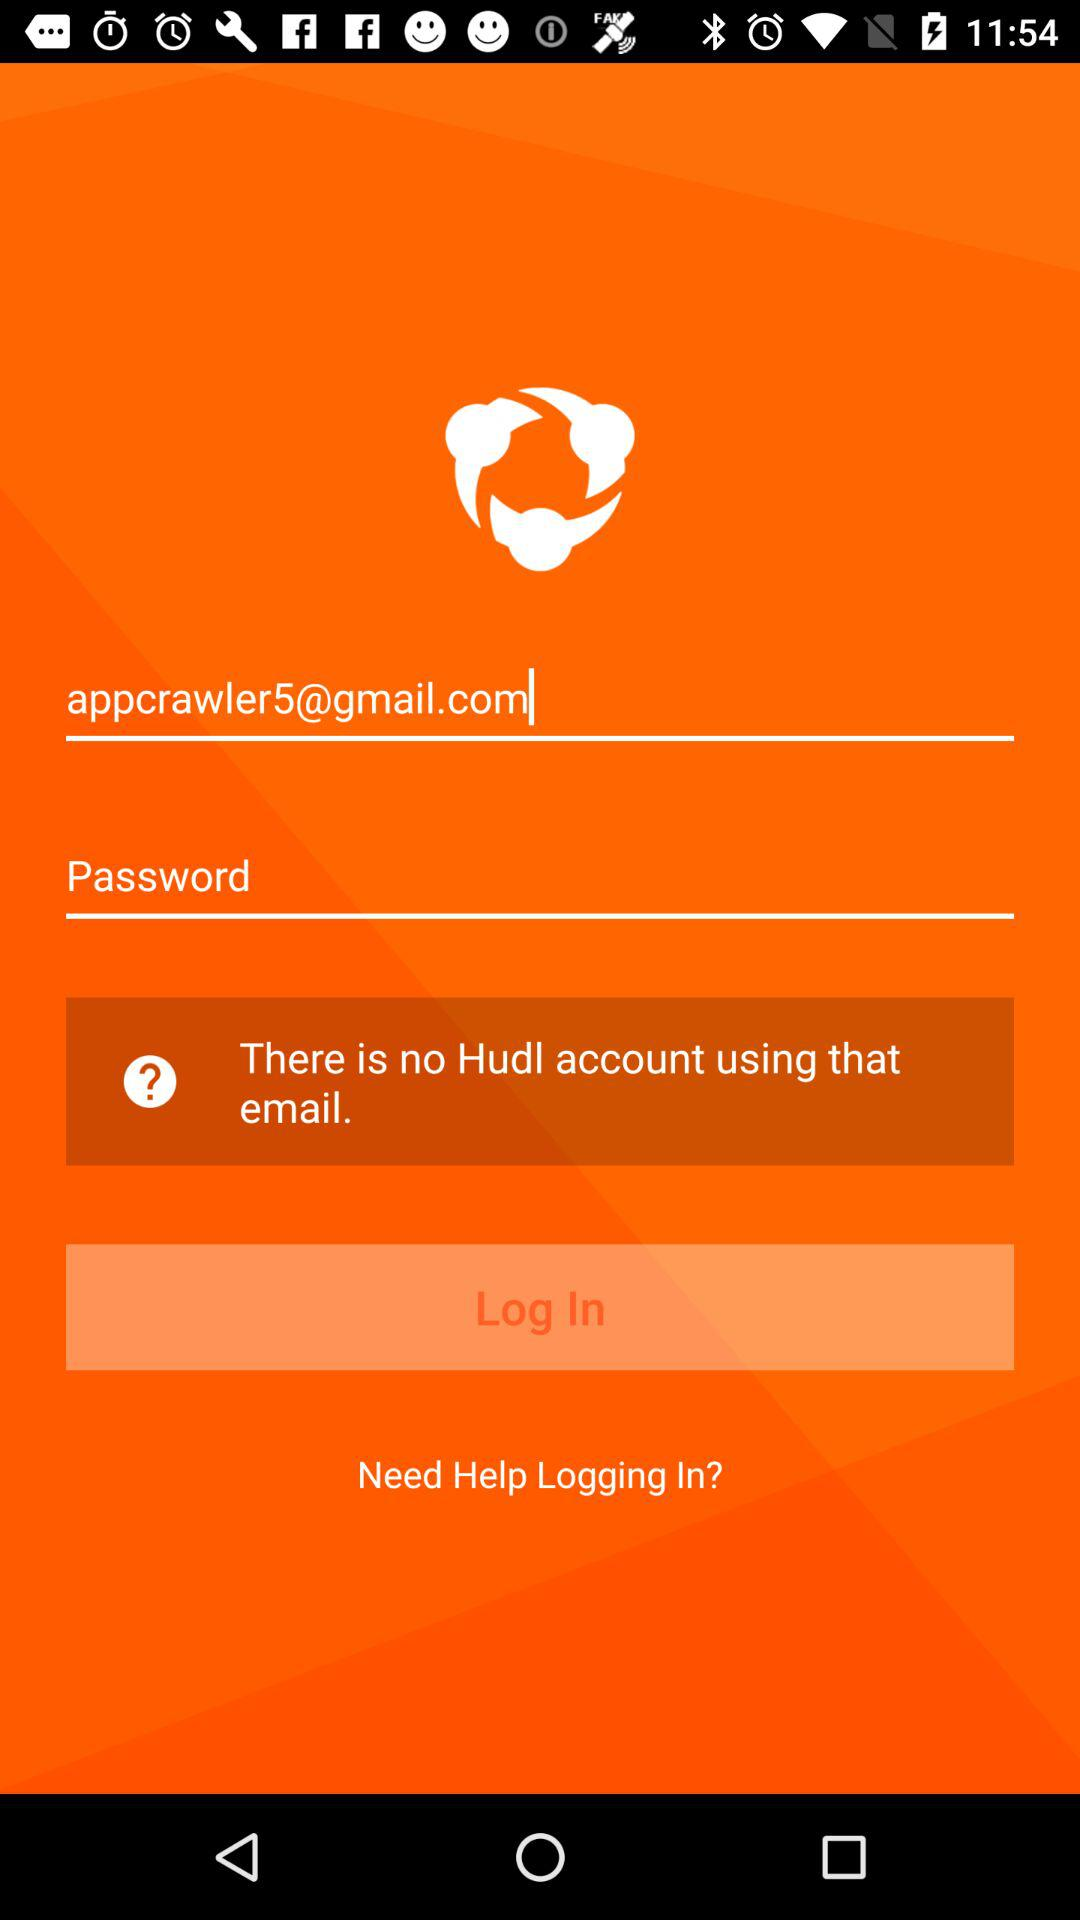How many characters must the password contain?
When the provided information is insufficient, respond with <no answer>. <no answer> 